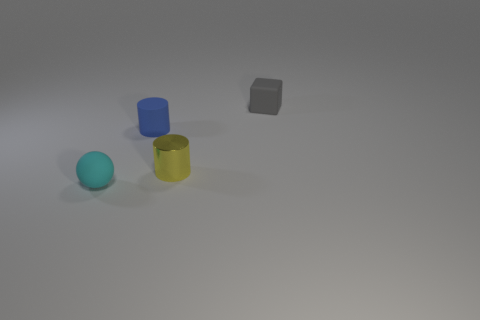The rubber object in front of the tiny metal cylinder has what shape?
Your answer should be compact. Sphere. There is a cylinder in front of the tiny cylinder left of the small metallic object that is right of the rubber cylinder; what is it made of?
Your response must be concise. Metal. What number of other things are the same size as the gray block?
Your answer should be compact. 3. There is another object that is the same shape as the blue rubber object; what is it made of?
Give a very brief answer. Metal. The shiny object is what color?
Ensure brevity in your answer.  Yellow. What is the color of the small rubber thing right of the tiny cylinder to the right of the blue object?
Your answer should be compact. Gray. There is a object that is to the left of the cylinder behind the small yellow thing; how many small blue matte objects are in front of it?
Your response must be concise. 0. Are there any small gray things on the right side of the matte cylinder?
Ensure brevity in your answer.  Yes. Is there anything else that has the same color as the small block?
Ensure brevity in your answer.  No. How many cylinders are either cyan matte objects or small yellow shiny things?
Offer a very short reply. 1. 